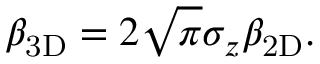Convert formula to latex. <formula><loc_0><loc_0><loc_500><loc_500>\beta _ { 3 D } = 2 \sqrt { \pi } \sigma _ { z } \beta _ { 2 D } .</formula> 